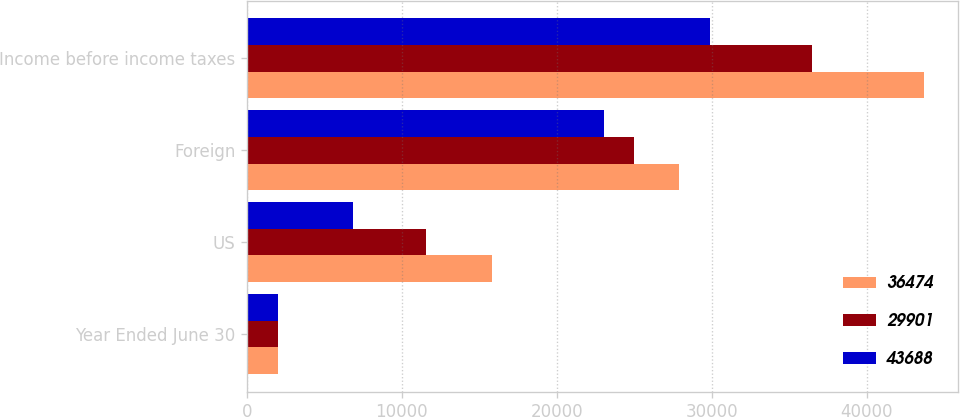<chart> <loc_0><loc_0><loc_500><loc_500><stacked_bar_chart><ecel><fcel>Year Ended June 30<fcel>US<fcel>Foreign<fcel>Income before income taxes<nl><fcel>36474<fcel>2019<fcel>15799<fcel>27889<fcel>43688<nl><fcel>29901<fcel>2018<fcel>11527<fcel>24947<fcel>36474<nl><fcel>43688<fcel>2017<fcel>6843<fcel>23058<fcel>29901<nl></chart> 